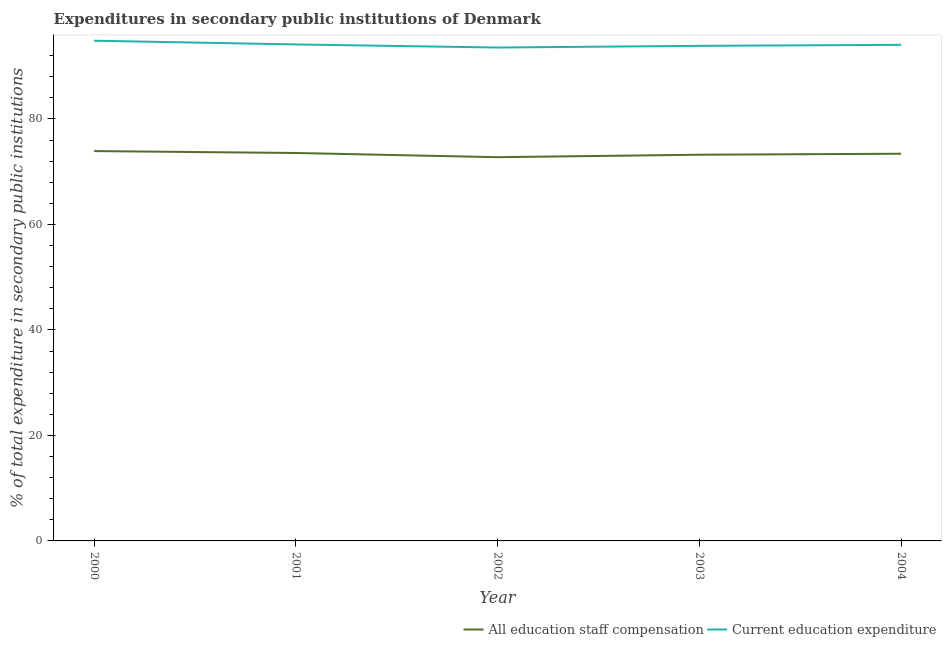Is the number of lines equal to the number of legend labels?
Make the answer very short. Yes. What is the expenditure in staff compensation in 2003?
Your response must be concise. 73.21. Across all years, what is the maximum expenditure in education?
Offer a very short reply. 94.83. Across all years, what is the minimum expenditure in education?
Provide a succinct answer. 93.53. What is the total expenditure in education in the graph?
Make the answer very short. 470.38. What is the difference between the expenditure in education in 2000 and that in 2004?
Offer a very short reply. 0.78. What is the difference between the expenditure in staff compensation in 2003 and the expenditure in education in 2002?
Offer a terse response. -20.32. What is the average expenditure in staff compensation per year?
Give a very brief answer. 73.36. In the year 2002, what is the difference between the expenditure in staff compensation and expenditure in education?
Your response must be concise. -20.79. In how many years, is the expenditure in staff compensation greater than 76 %?
Offer a terse response. 0. What is the ratio of the expenditure in staff compensation in 2000 to that in 2004?
Provide a short and direct response. 1.01. What is the difference between the highest and the second highest expenditure in education?
Offer a terse response. 0.71. What is the difference between the highest and the lowest expenditure in staff compensation?
Your answer should be compact. 1.16. Is the sum of the expenditure in education in 2002 and 2003 greater than the maximum expenditure in staff compensation across all years?
Provide a short and direct response. Yes. Are the values on the major ticks of Y-axis written in scientific E-notation?
Your answer should be very brief. No. Does the graph contain any zero values?
Keep it short and to the point. No. Where does the legend appear in the graph?
Provide a short and direct response. Bottom right. What is the title of the graph?
Provide a short and direct response. Expenditures in secondary public institutions of Denmark. What is the label or title of the Y-axis?
Make the answer very short. % of total expenditure in secondary public institutions. What is the % of total expenditure in secondary public institutions in All education staff compensation in 2000?
Keep it short and to the point. 73.9. What is the % of total expenditure in secondary public institutions of Current education expenditure in 2000?
Your response must be concise. 94.83. What is the % of total expenditure in secondary public institutions of All education staff compensation in 2001?
Ensure brevity in your answer.  73.54. What is the % of total expenditure in secondary public institutions in Current education expenditure in 2001?
Give a very brief answer. 94.12. What is the % of total expenditure in secondary public institutions in All education staff compensation in 2002?
Your answer should be compact. 72.74. What is the % of total expenditure in secondary public institutions in Current education expenditure in 2002?
Your response must be concise. 93.53. What is the % of total expenditure in secondary public institutions of All education staff compensation in 2003?
Offer a terse response. 73.21. What is the % of total expenditure in secondary public institutions of Current education expenditure in 2003?
Your answer should be very brief. 93.85. What is the % of total expenditure in secondary public institutions in All education staff compensation in 2004?
Your answer should be compact. 73.4. What is the % of total expenditure in secondary public institutions in Current education expenditure in 2004?
Offer a terse response. 94.05. Across all years, what is the maximum % of total expenditure in secondary public institutions in All education staff compensation?
Your response must be concise. 73.9. Across all years, what is the maximum % of total expenditure in secondary public institutions in Current education expenditure?
Ensure brevity in your answer.  94.83. Across all years, what is the minimum % of total expenditure in secondary public institutions of All education staff compensation?
Offer a terse response. 72.74. Across all years, what is the minimum % of total expenditure in secondary public institutions in Current education expenditure?
Your answer should be compact. 93.53. What is the total % of total expenditure in secondary public institutions in All education staff compensation in the graph?
Keep it short and to the point. 366.8. What is the total % of total expenditure in secondary public institutions of Current education expenditure in the graph?
Keep it short and to the point. 470.38. What is the difference between the % of total expenditure in secondary public institutions of All education staff compensation in 2000 and that in 2001?
Your answer should be very brief. 0.36. What is the difference between the % of total expenditure in secondary public institutions in Current education expenditure in 2000 and that in 2001?
Give a very brief answer. 0.71. What is the difference between the % of total expenditure in secondary public institutions in All education staff compensation in 2000 and that in 2002?
Keep it short and to the point. 1.16. What is the difference between the % of total expenditure in secondary public institutions of Current education expenditure in 2000 and that in 2002?
Make the answer very short. 1.29. What is the difference between the % of total expenditure in secondary public institutions of All education staff compensation in 2000 and that in 2003?
Your answer should be very brief. 0.69. What is the difference between the % of total expenditure in secondary public institutions in Current education expenditure in 2000 and that in 2003?
Provide a short and direct response. 0.97. What is the difference between the % of total expenditure in secondary public institutions in All education staff compensation in 2000 and that in 2004?
Your answer should be compact. 0.5. What is the difference between the % of total expenditure in secondary public institutions in Current education expenditure in 2000 and that in 2004?
Provide a short and direct response. 0.78. What is the difference between the % of total expenditure in secondary public institutions in All education staff compensation in 2001 and that in 2002?
Ensure brevity in your answer.  0.8. What is the difference between the % of total expenditure in secondary public institutions of Current education expenditure in 2001 and that in 2002?
Provide a short and direct response. 0.59. What is the difference between the % of total expenditure in secondary public institutions in All education staff compensation in 2001 and that in 2003?
Make the answer very short. 0.33. What is the difference between the % of total expenditure in secondary public institutions in Current education expenditure in 2001 and that in 2003?
Ensure brevity in your answer.  0.27. What is the difference between the % of total expenditure in secondary public institutions in All education staff compensation in 2001 and that in 2004?
Your answer should be compact. 0.14. What is the difference between the % of total expenditure in secondary public institutions of Current education expenditure in 2001 and that in 2004?
Make the answer very short. 0.08. What is the difference between the % of total expenditure in secondary public institutions in All education staff compensation in 2002 and that in 2003?
Your answer should be compact. -0.47. What is the difference between the % of total expenditure in secondary public institutions in Current education expenditure in 2002 and that in 2003?
Offer a very short reply. -0.32. What is the difference between the % of total expenditure in secondary public institutions in All education staff compensation in 2002 and that in 2004?
Provide a short and direct response. -0.65. What is the difference between the % of total expenditure in secondary public institutions of Current education expenditure in 2002 and that in 2004?
Keep it short and to the point. -0.51. What is the difference between the % of total expenditure in secondary public institutions of All education staff compensation in 2003 and that in 2004?
Make the answer very short. -0.19. What is the difference between the % of total expenditure in secondary public institutions of Current education expenditure in 2003 and that in 2004?
Keep it short and to the point. -0.19. What is the difference between the % of total expenditure in secondary public institutions of All education staff compensation in 2000 and the % of total expenditure in secondary public institutions of Current education expenditure in 2001?
Offer a very short reply. -20.22. What is the difference between the % of total expenditure in secondary public institutions of All education staff compensation in 2000 and the % of total expenditure in secondary public institutions of Current education expenditure in 2002?
Ensure brevity in your answer.  -19.63. What is the difference between the % of total expenditure in secondary public institutions in All education staff compensation in 2000 and the % of total expenditure in secondary public institutions in Current education expenditure in 2003?
Provide a succinct answer. -19.95. What is the difference between the % of total expenditure in secondary public institutions of All education staff compensation in 2000 and the % of total expenditure in secondary public institutions of Current education expenditure in 2004?
Provide a succinct answer. -20.14. What is the difference between the % of total expenditure in secondary public institutions in All education staff compensation in 2001 and the % of total expenditure in secondary public institutions in Current education expenditure in 2002?
Make the answer very short. -19.99. What is the difference between the % of total expenditure in secondary public institutions in All education staff compensation in 2001 and the % of total expenditure in secondary public institutions in Current education expenditure in 2003?
Provide a short and direct response. -20.31. What is the difference between the % of total expenditure in secondary public institutions in All education staff compensation in 2001 and the % of total expenditure in secondary public institutions in Current education expenditure in 2004?
Provide a short and direct response. -20.5. What is the difference between the % of total expenditure in secondary public institutions of All education staff compensation in 2002 and the % of total expenditure in secondary public institutions of Current education expenditure in 2003?
Offer a terse response. -21.11. What is the difference between the % of total expenditure in secondary public institutions of All education staff compensation in 2002 and the % of total expenditure in secondary public institutions of Current education expenditure in 2004?
Provide a short and direct response. -21.3. What is the difference between the % of total expenditure in secondary public institutions in All education staff compensation in 2003 and the % of total expenditure in secondary public institutions in Current education expenditure in 2004?
Offer a terse response. -20.83. What is the average % of total expenditure in secondary public institutions in All education staff compensation per year?
Your answer should be very brief. 73.36. What is the average % of total expenditure in secondary public institutions in Current education expenditure per year?
Provide a short and direct response. 94.08. In the year 2000, what is the difference between the % of total expenditure in secondary public institutions of All education staff compensation and % of total expenditure in secondary public institutions of Current education expenditure?
Your answer should be very brief. -20.93. In the year 2001, what is the difference between the % of total expenditure in secondary public institutions in All education staff compensation and % of total expenditure in secondary public institutions in Current education expenditure?
Provide a short and direct response. -20.58. In the year 2002, what is the difference between the % of total expenditure in secondary public institutions of All education staff compensation and % of total expenditure in secondary public institutions of Current education expenditure?
Offer a very short reply. -20.79. In the year 2003, what is the difference between the % of total expenditure in secondary public institutions of All education staff compensation and % of total expenditure in secondary public institutions of Current education expenditure?
Your response must be concise. -20.64. In the year 2004, what is the difference between the % of total expenditure in secondary public institutions of All education staff compensation and % of total expenditure in secondary public institutions of Current education expenditure?
Offer a terse response. -20.65. What is the ratio of the % of total expenditure in secondary public institutions of All education staff compensation in 2000 to that in 2001?
Provide a short and direct response. 1. What is the ratio of the % of total expenditure in secondary public institutions in Current education expenditure in 2000 to that in 2001?
Provide a short and direct response. 1.01. What is the ratio of the % of total expenditure in secondary public institutions of All education staff compensation in 2000 to that in 2002?
Provide a succinct answer. 1.02. What is the ratio of the % of total expenditure in secondary public institutions of Current education expenditure in 2000 to that in 2002?
Give a very brief answer. 1.01. What is the ratio of the % of total expenditure in secondary public institutions in All education staff compensation in 2000 to that in 2003?
Ensure brevity in your answer.  1.01. What is the ratio of the % of total expenditure in secondary public institutions of Current education expenditure in 2000 to that in 2003?
Offer a terse response. 1.01. What is the ratio of the % of total expenditure in secondary public institutions in All education staff compensation in 2000 to that in 2004?
Offer a terse response. 1.01. What is the ratio of the % of total expenditure in secondary public institutions in Current education expenditure in 2000 to that in 2004?
Ensure brevity in your answer.  1.01. What is the ratio of the % of total expenditure in secondary public institutions of All education staff compensation in 2001 to that in 2002?
Your response must be concise. 1.01. What is the ratio of the % of total expenditure in secondary public institutions in Current education expenditure in 2001 to that in 2002?
Make the answer very short. 1.01. What is the ratio of the % of total expenditure in secondary public institutions in All education staff compensation in 2001 to that in 2003?
Your answer should be compact. 1. What is the ratio of the % of total expenditure in secondary public institutions of Current education expenditure in 2001 to that in 2003?
Provide a short and direct response. 1. What is the ratio of the % of total expenditure in secondary public institutions in Current education expenditure in 2001 to that in 2004?
Ensure brevity in your answer.  1. What is the ratio of the % of total expenditure in secondary public institutions in All education staff compensation in 2002 to that in 2003?
Keep it short and to the point. 0.99. What is the ratio of the % of total expenditure in secondary public institutions of Current education expenditure in 2002 to that in 2004?
Your response must be concise. 0.99. What is the ratio of the % of total expenditure in secondary public institutions in All education staff compensation in 2003 to that in 2004?
Offer a very short reply. 1. What is the ratio of the % of total expenditure in secondary public institutions in Current education expenditure in 2003 to that in 2004?
Offer a very short reply. 1. What is the difference between the highest and the second highest % of total expenditure in secondary public institutions in All education staff compensation?
Provide a succinct answer. 0.36. What is the difference between the highest and the second highest % of total expenditure in secondary public institutions of Current education expenditure?
Ensure brevity in your answer.  0.71. What is the difference between the highest and the lowest % of total expenditure in secondary public institutions of All education staff compensation?
Your answer should be compact. 1.16. What is the difference between the highest and the lowest % of total expenditure in secondary public institutions of Current education expenditure?
Ensure brevity in your answer.  1.29. 